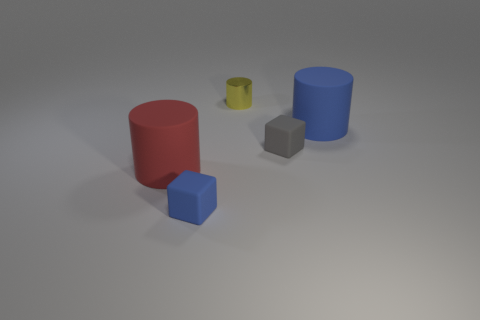Is there a blue matte thing on the left side of the blue object behind the small gray rubber cube?
Provide a short and direct response. Yes. What is the yellow object made of?
Your answer should be very brief. Metal. Are the tiny object that is on the right side of the tiny yellow shiny object and the large cylinder that is on the left side of the tiny blue object made of the same material?
Ensure brevity in your answer.  Yes. Is there any other thing that is the same color as the metal cylinder?
Your answer should be compact. No. There is another matte object that is the same shape as the small blue object; what is its color?
Offer a terse response. Gray. There is a rubber thing that is on the left side of the gray cube and behind the tiny blue matte block; what is its size?
Your answer should be very brief. Large. There is a large rubber thing that is on the left side of the metallic cylinder; is it the same shape as the big object that is right of the tiny metallic cylinder?
Give a very brief answer. Yes. What number of big red things are made of the same material as the large red cylinder?
Offer a very short reply. 0. What is the shape of the tiny thing that is both in front of the tiny yellow object and right of the blue matte cube?
Provide a succinct answer. Cube. Do the cylinder that is to the right of the yellow cylinder and the red cylinder have the same material?
Your answer should be very brief. Yes. 